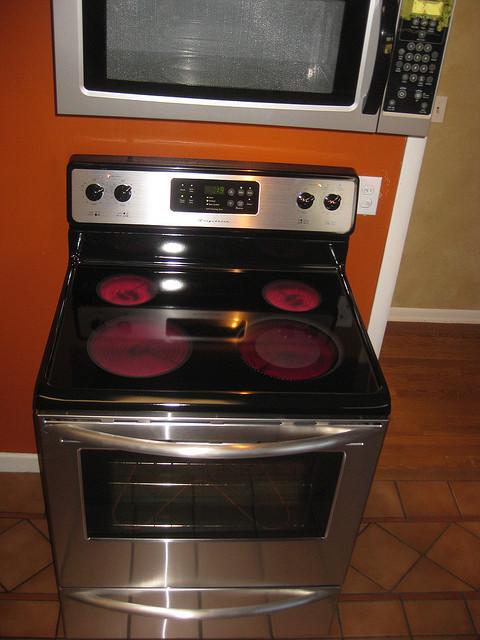Is the stove on?
Short answer required. Yes. What is in the picture?
Give a very brief answer. Stove. What is the microwave made of?
Keep it brief. Stainless steel. 